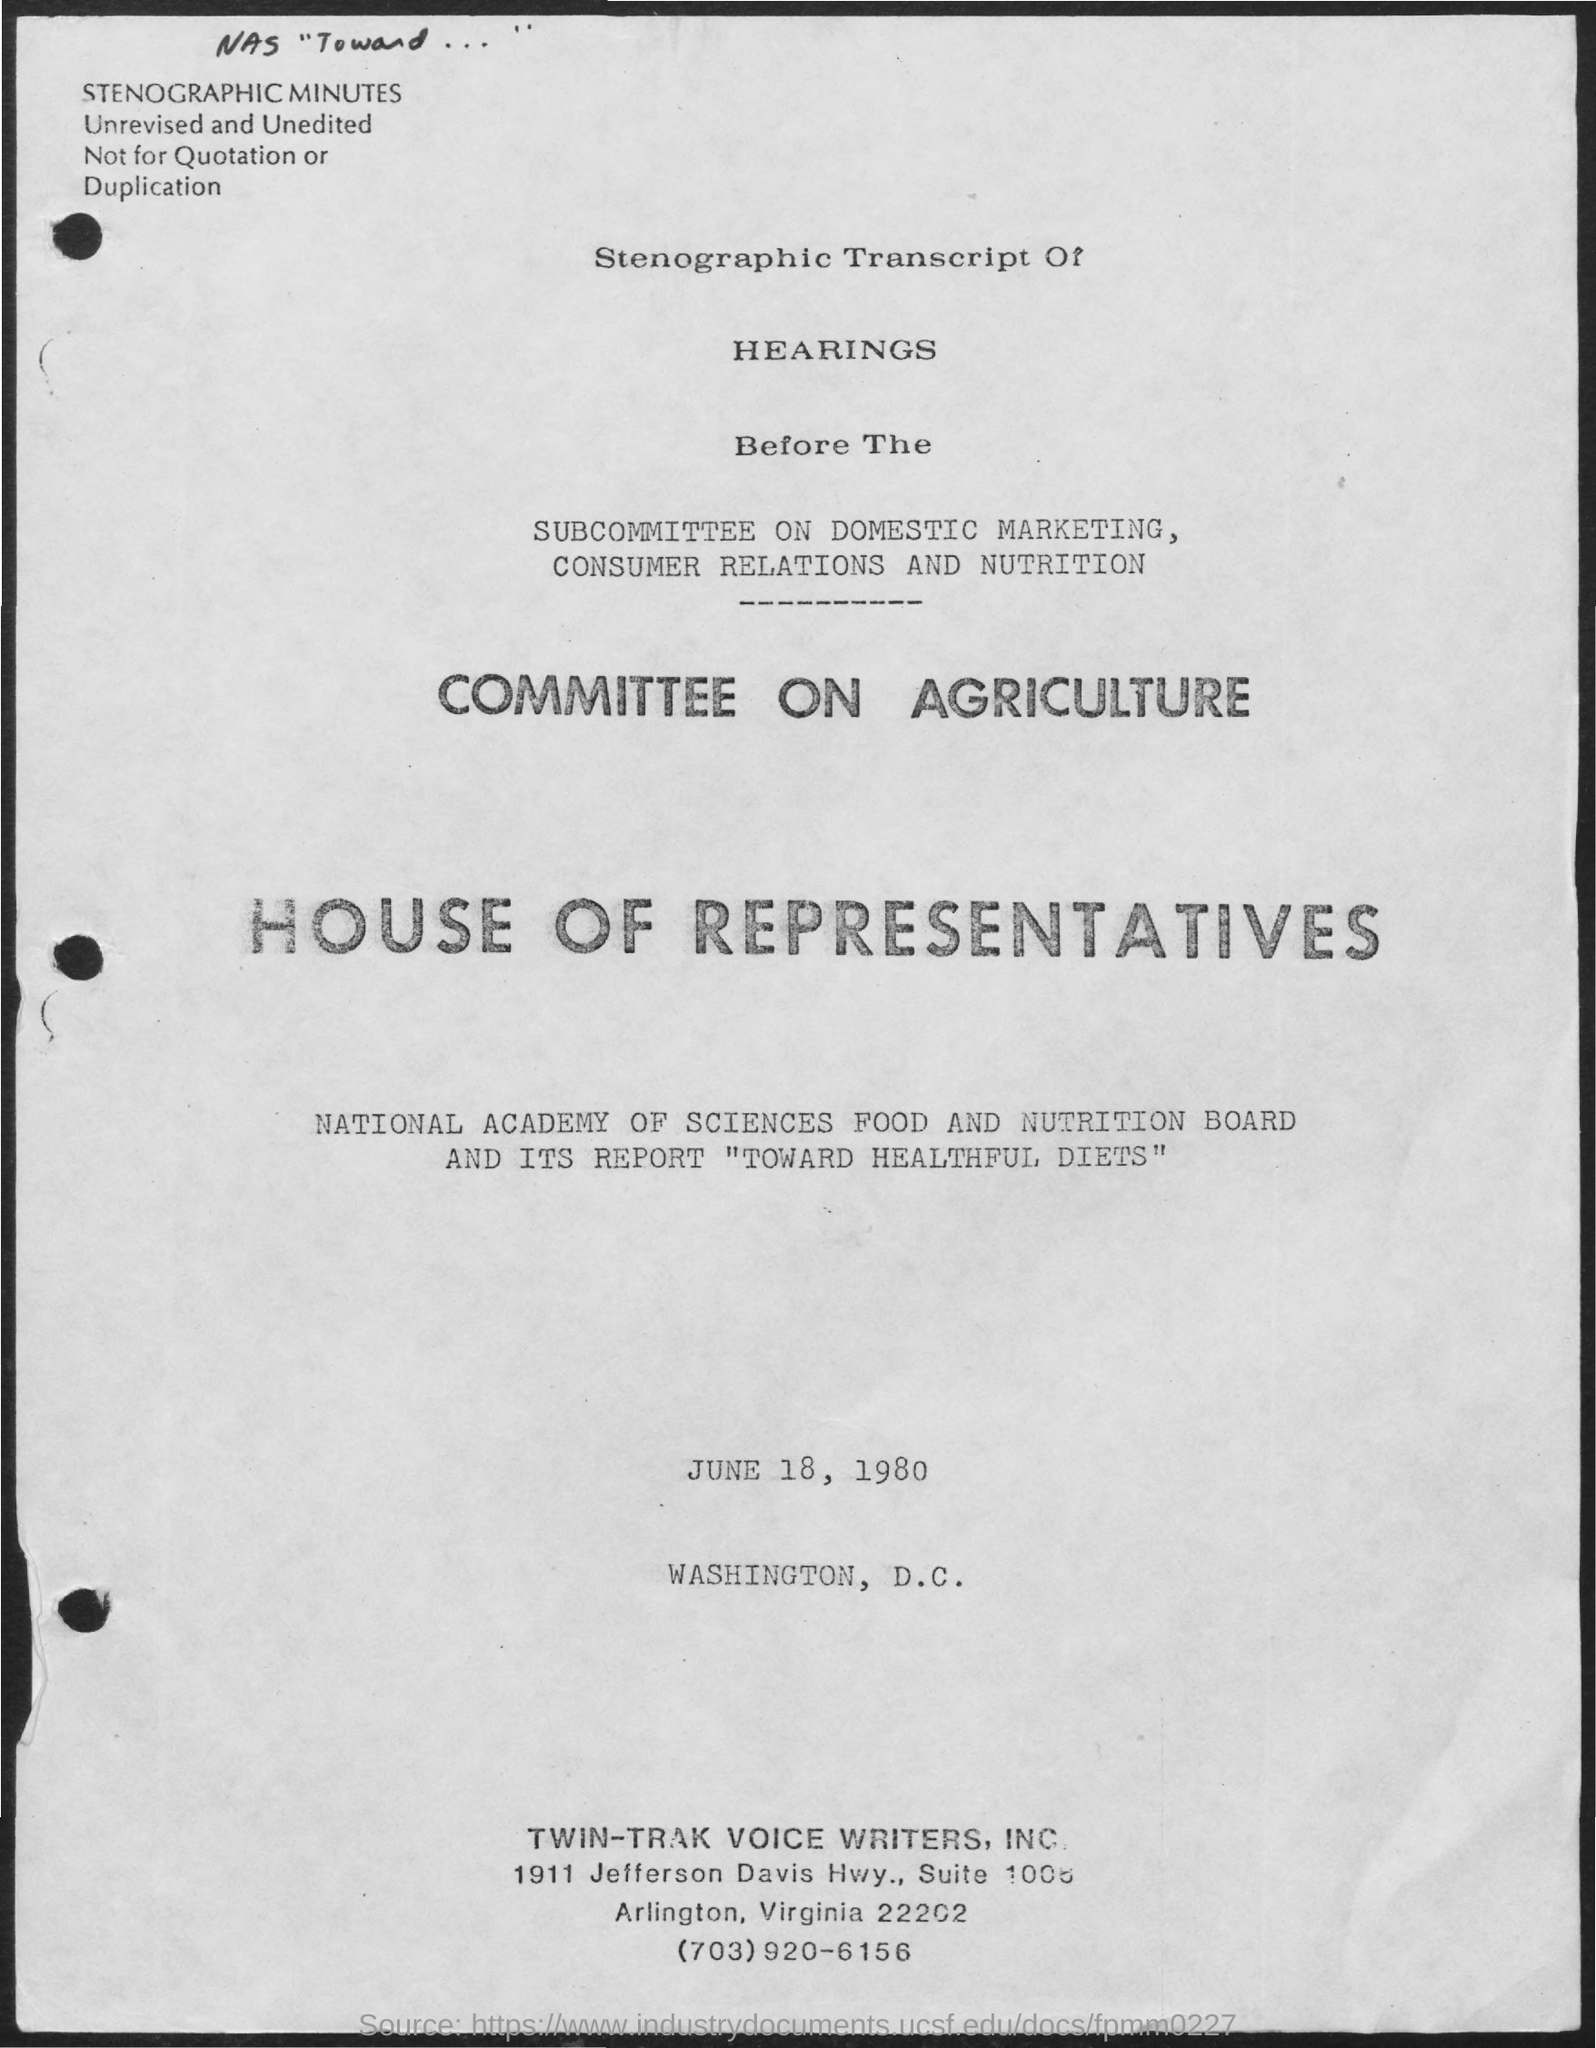List a handful of essential elements in this visual. The committee is based on the committee on agriculture. The date mentioned in the given page is June 18, 1980. 